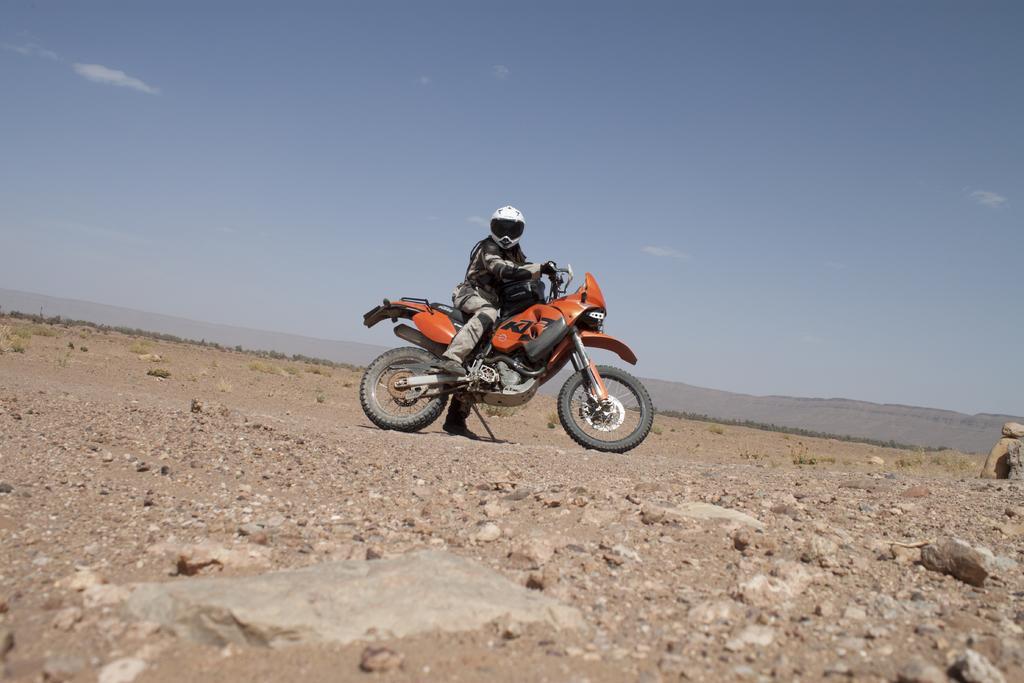Could you give a brief overview of what you see in this image? In this image in the front there are stones on the ground. In the center there is a man sitting on a bike which is orange in colour and the sky is cloudy. 